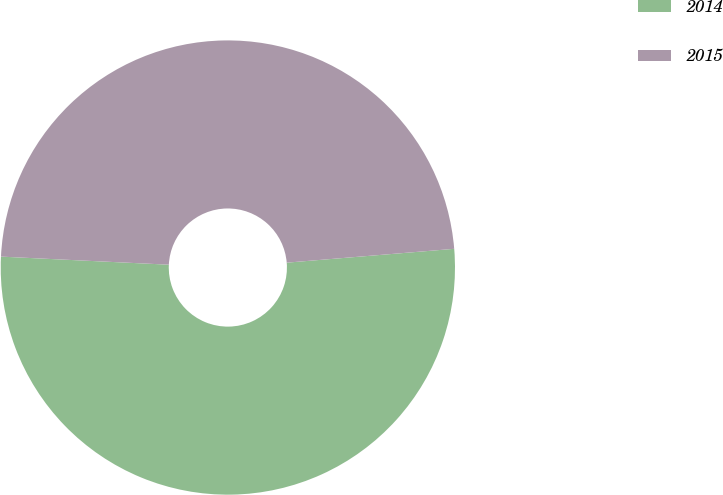<chart> <loc_0><loc_0><loc_500><loc_500><pie_chart><fcel>2014<fcel>2015<nl><fcel>52.08%<fcel>47.92%<nl></chart> 